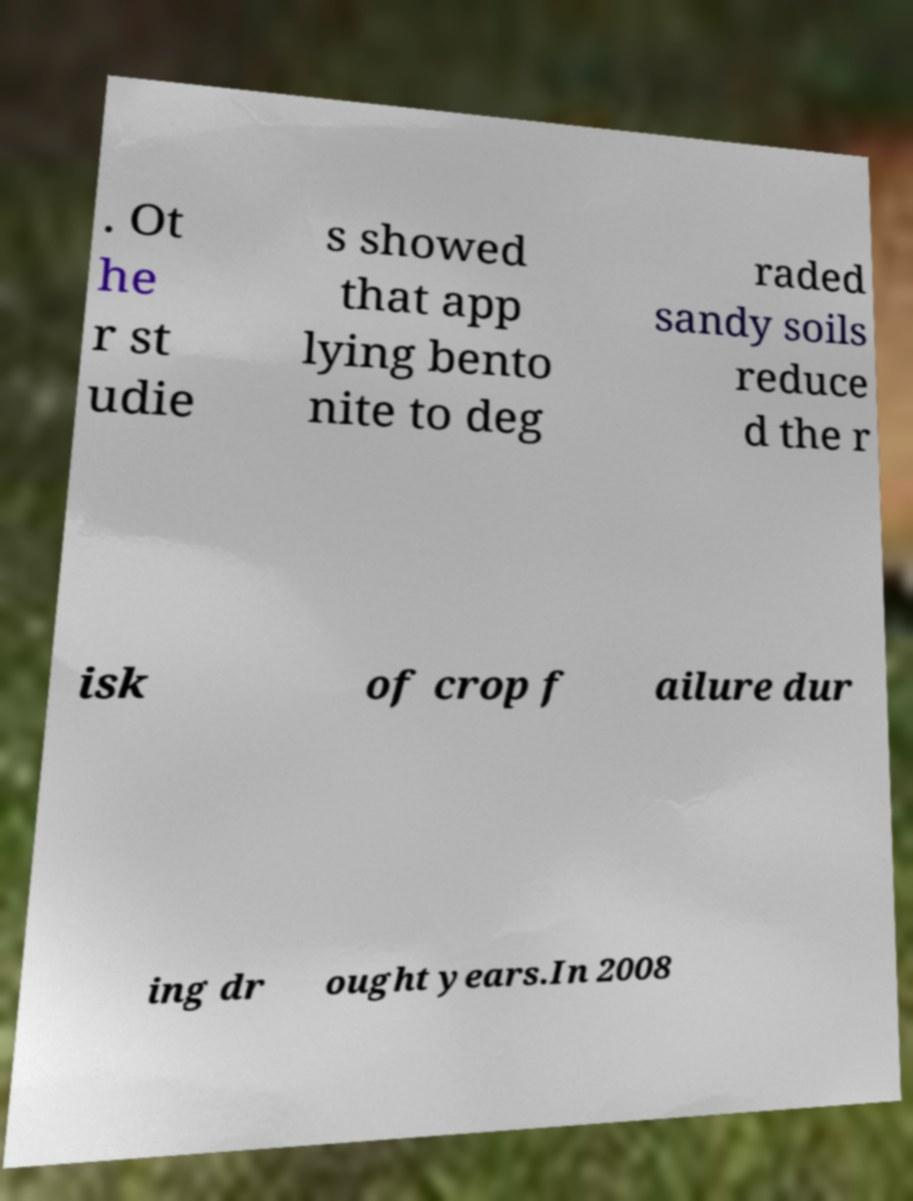Please identify and transcribe the text found in this image. . Ot he r st udie s showed that app lying bento nite to deg raded sandy soils reduce d the r isk of crop f ailure dur ing dr ought years.In 2008 